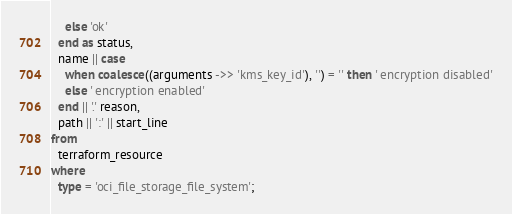<code> <loc_0><loc_0><loc_500><loc_500><_SQL_>    else 'ok'
  end as status,
  name || case
    when coalesce((arguments ->> 'kms_key_id'), '') = '' then ' encryption disabled'
    else ' encryption enabled'
  end || '.' reason,
  path || ':' || start_line
from
  terraform_resource
where
  type = 'oci_file_storage_file_system';</code> 